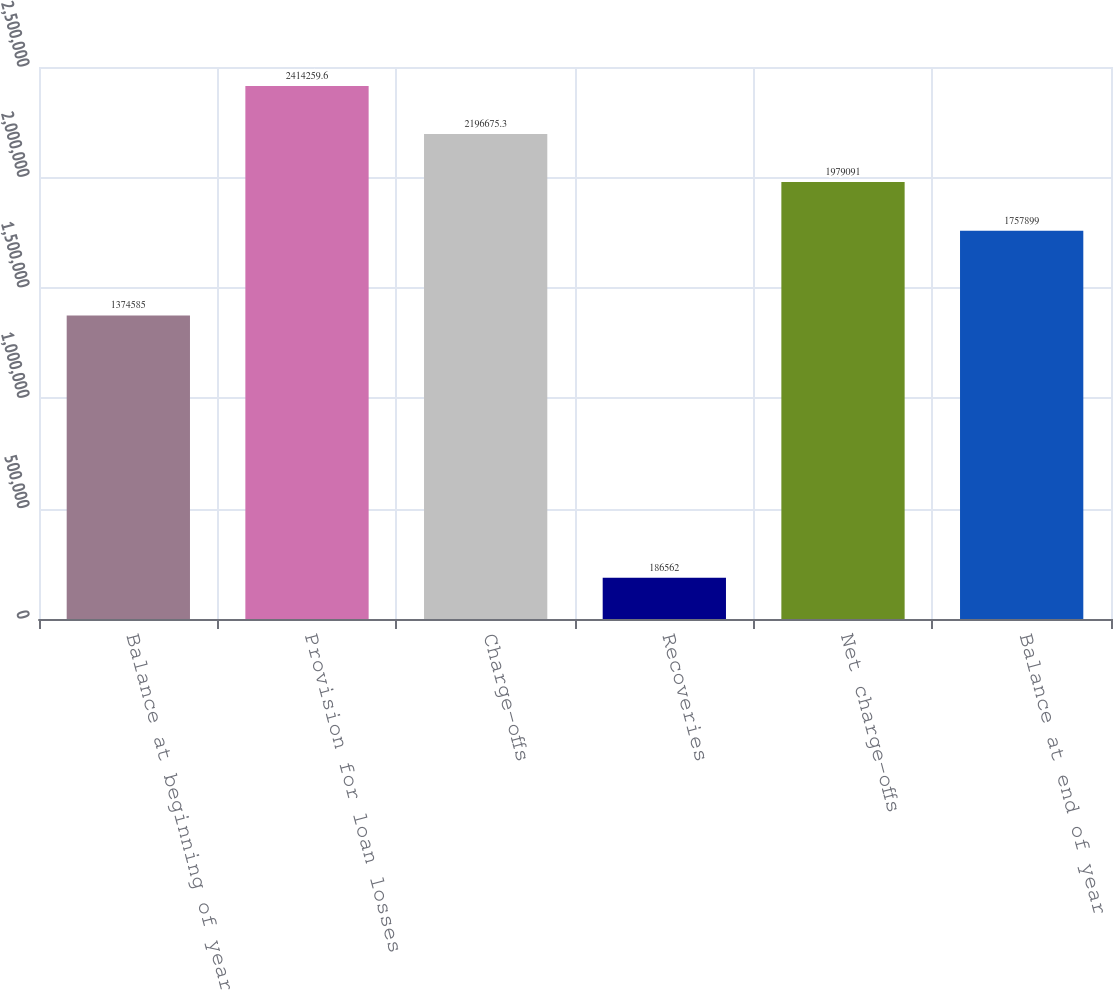<chart> <loc_0><loc_0><loc_500><loc_500><bar_chart><fcel>Balance at beginning of year<fcel>Provision for loan losses<fcel>Charge-offs<fcel>Recoveries<fcel>Net charge-offs<fcel>Balance at end of year<nl><fcel>1.37458e+06<fcel>2.41426e+06<fcel>2.19668e+06<fcel>186562<fcel>1.97909e+06<fcel>1.7579e+06<nl></chart> 